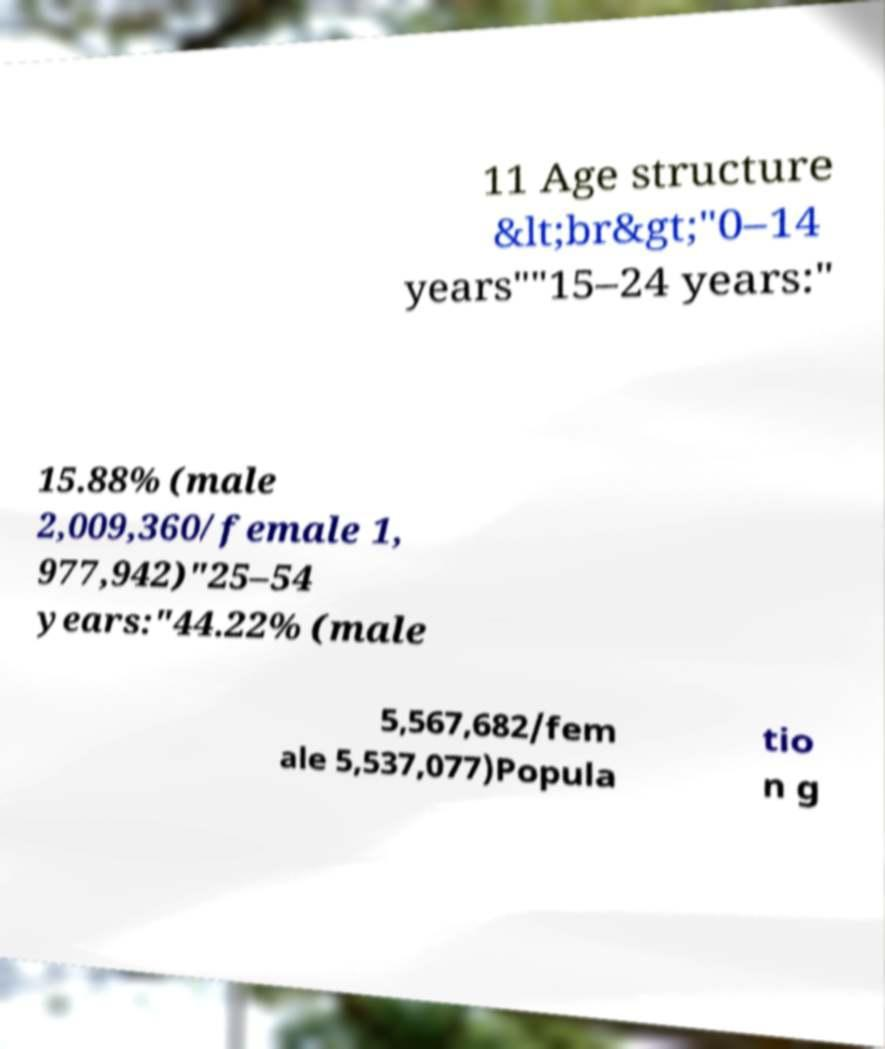Could you extract and type out the text from this image? 11 Age structure &lt;br&gt;"0–14 years""15–24 years:" 15.88% (male 2,009,360/female 1, 977,942)"25–54 years:"44.22% (male 5,567,682/fem ale 5,537,077)Popula tio n g 